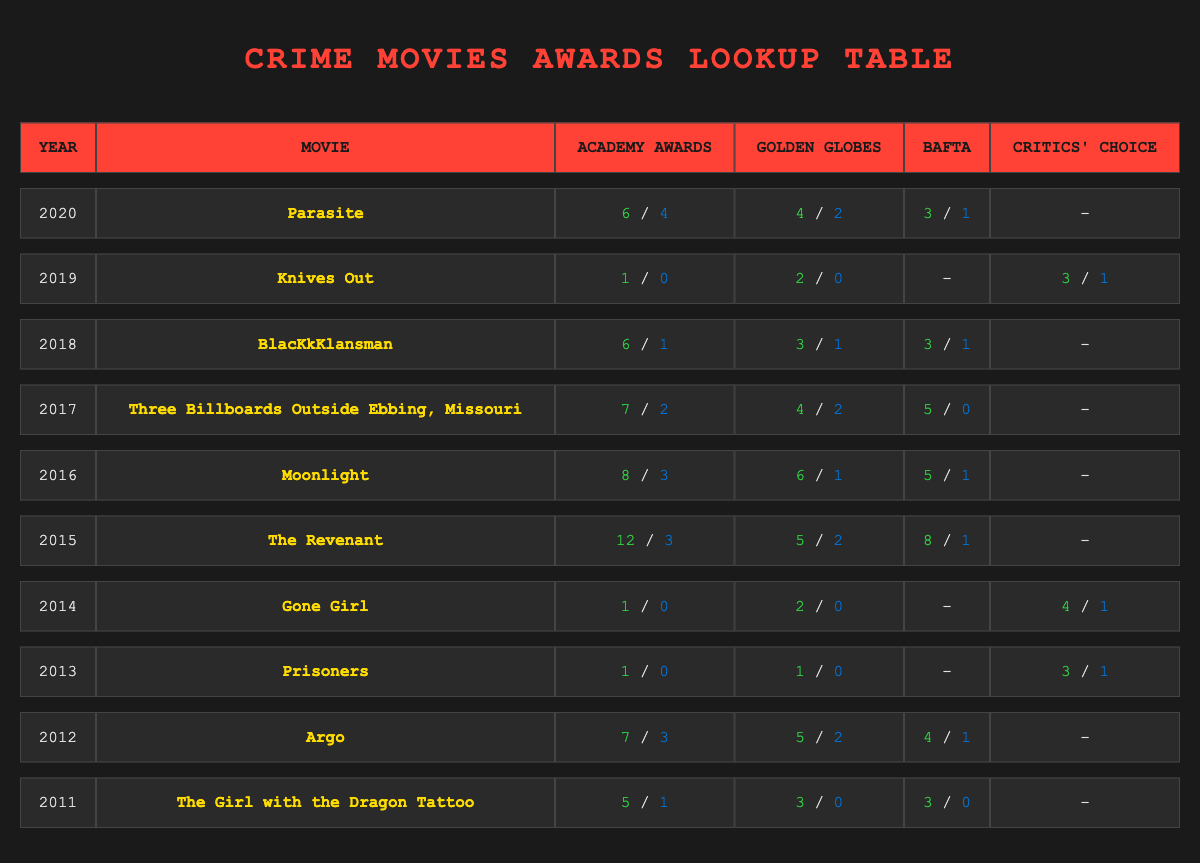What movie won the most Academy Awards in 2020? The table shows that "Parasite" won 4 Academy Awards in 2020.
Answer: Parasite Which film received the highest number of nominations for the Academy Awards between 2015 and 2020? Summing the nominations from 2015 to 2020: "The Revenant" has 12 (2015), "Moonlight" has 8 (2016), "Three Billboards Outside Ebbing, Missouri" has 7 (2017), "BlacKkKlansman" has 6 (2018), and "Parasite" has 6 (2020). The highest number is 12 by "The Revenant."
Answer: The Revenant Was "Gone Girl" nominated for an Academy Award? According to the table, "Gone Girl" has 1 nomination for the Academy Awards in 2014, which means it was nominated.
Answer: Yes Which movie had the most wins in the Golden Globes category in 2016? The table indicates that "Moonlight" won 1 Golden Globe out of 6 nominations in 2016. It is the only film listed in that year, thus it is the only film discussed.
Answer: Moonlight What is the total number of nominations for "Knives Out"? The table shows "Knives Out" received 1 nomination for the Academy Awards, 2 for the Golden Globes, and 3 for the Critics' Choice, totaling 1 + 2 + 3 = 6 nominations.
Answer: 6 Which film has the highest number of combined wins and nominations for the year 2015? In 2015, "The Revenant" had 12 nominations and 3 wins for Academy Awards, 5 nominations and 2 wins for Golden Globes, and 8 nominations and 1 win for BAFTA. This totals to 12 + 5 + 8 = 25 nominations and 3 + 2 + 1 = 6 wins, thus combined 25 + 6 = 31.
Answer: 31 Did any movie in the table not win any awards despite multiple nominations? Yes, "Knives Out" and "Gone Girl" both have nominations without wins in their respective categories.
Answer: Yes Which movie was the only one to receive more Golden Globe nominations than wins in the year 2017? According to the table, "Three Billboards Outside Ebbing, Missouri" got 4 nominations and won 2 Golden Globes in 2017. No other film in that year had a higher number of nominations.
Answer: Three Billboards Outside Ebbing, Missouri 